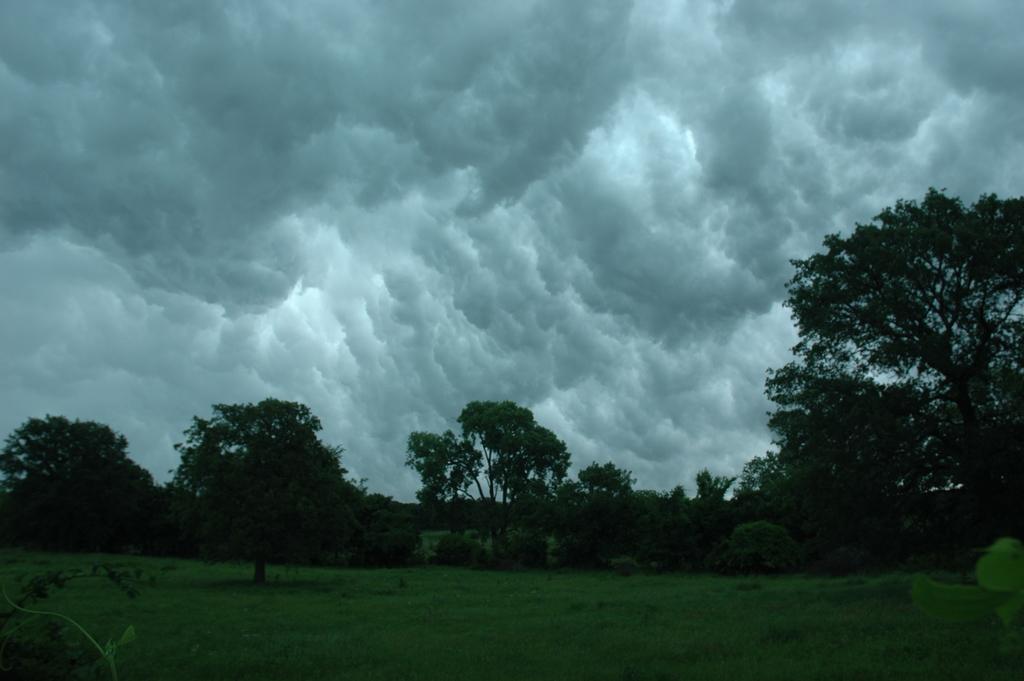Can you describe this image briefly? In this image we can see a group of trees, plants, grass and the sky which looks cloudy. 